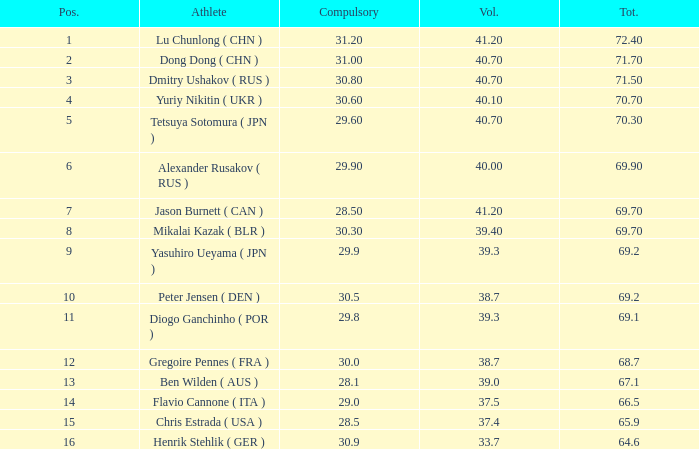9, and optional below 3 None. 